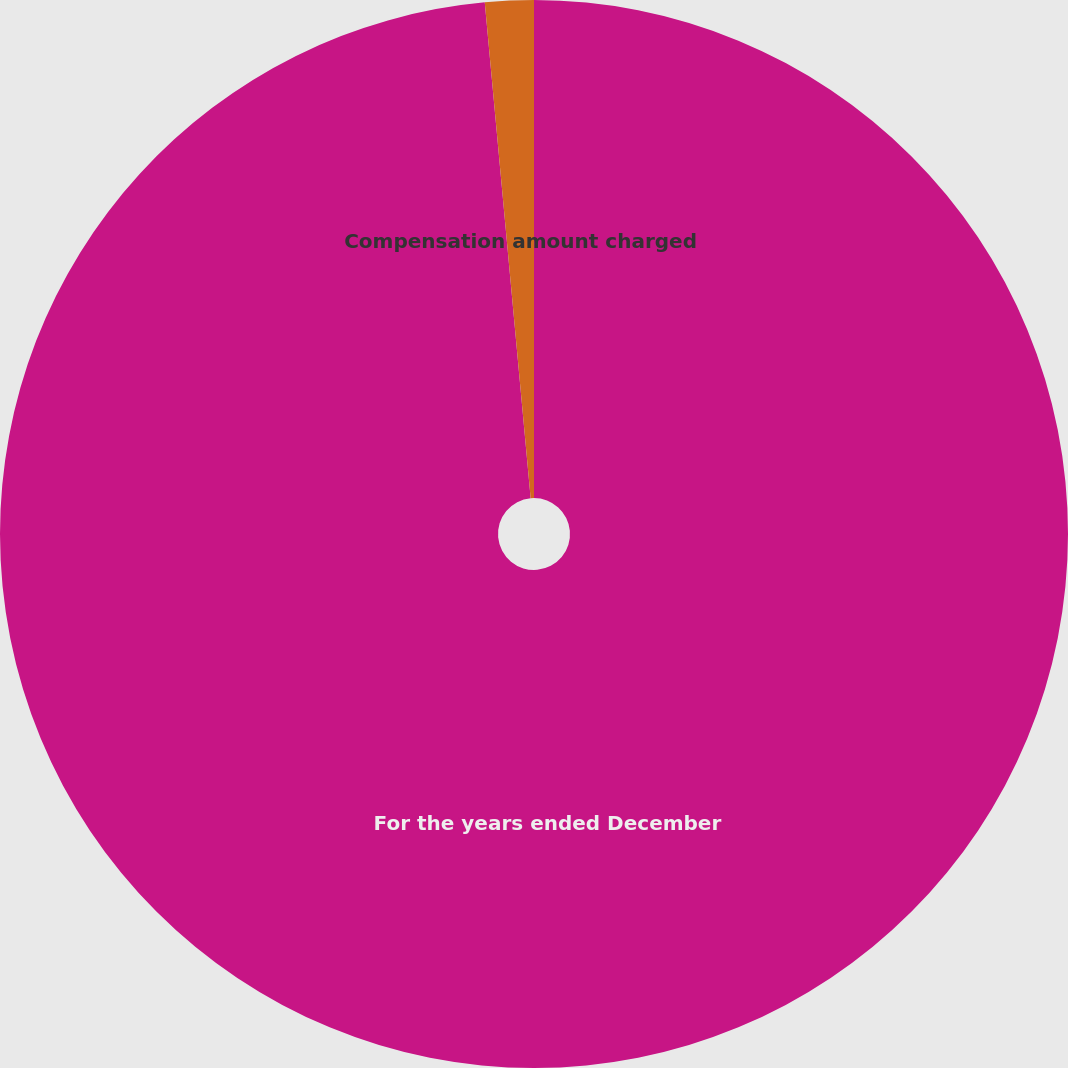Convert chart to OTSL. <chart><loc_0><loc_0><loc_500><loc_500><pie_chart><fcel>For the years ended December<fcel>Compensation amount charged<nl><fcel>98.53%<fcel>1.47%<nl></chart> 